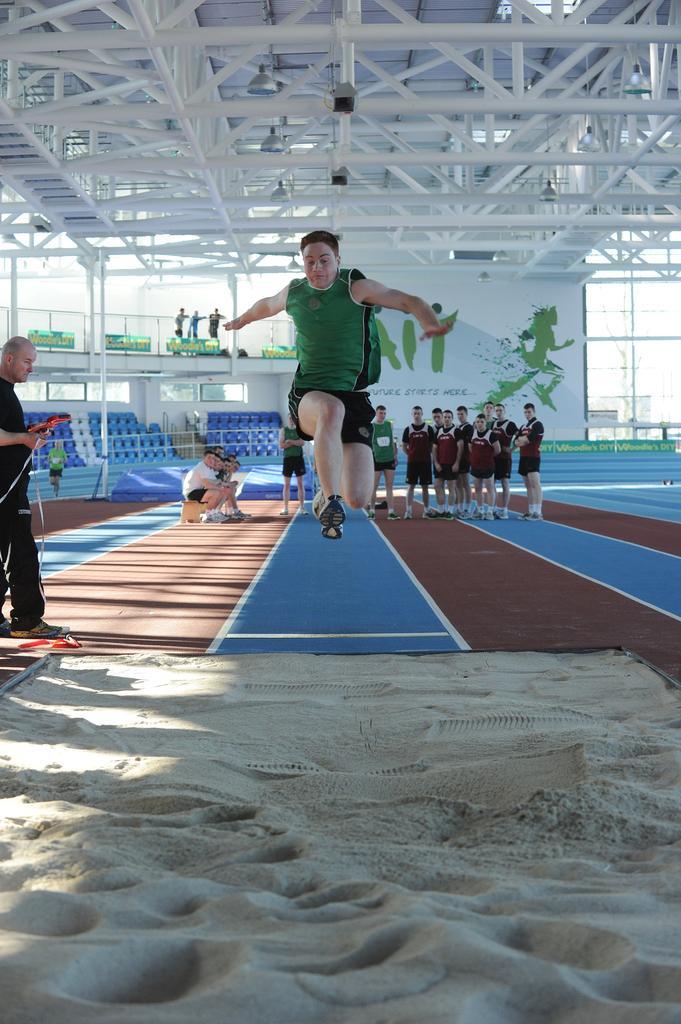Can you describe this image briefly? In the foreground of the picture there is sand. In the middle of the picture we can see a person jumping. On the left there is a person standing. In the background there are chairs, banner, people, running track and other objects. At the top there are iron frames and light. In the center of the background we can see three person standing by the railing. 